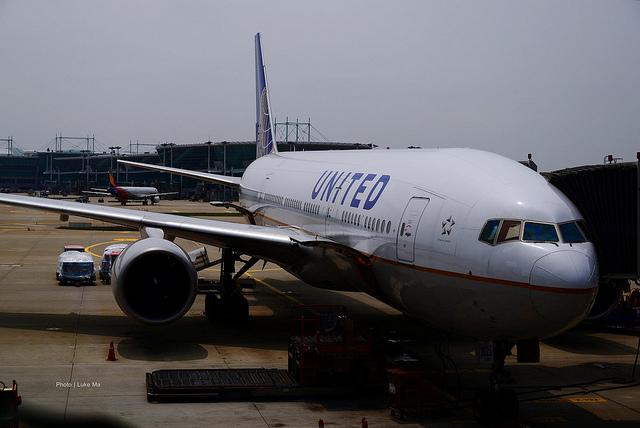Why is the plane sitting in the middle of the runway?
Keep it brief. Loading. What are the weather conditions at the airport?
Concise answer only. Overcast. How many people can be seen in the picture?
Quick response, please. 0. What company own this airplane?
Quick response, please. United. Are there other vehicles on the tarmac?
Keep it brief. Yes. What airline is the plane?
Short answer required. United. What airline is this?
Write a very short answer. United. What color is the plane?
Answer briefly. White. What type of plane is this?
Be succinct. United. What does it say on the plane?
Answer briefly. United. Is the weather being overcast with clouds?
Short answer required. Yes. Is this a un plane?
Concise answer only. Yes. 